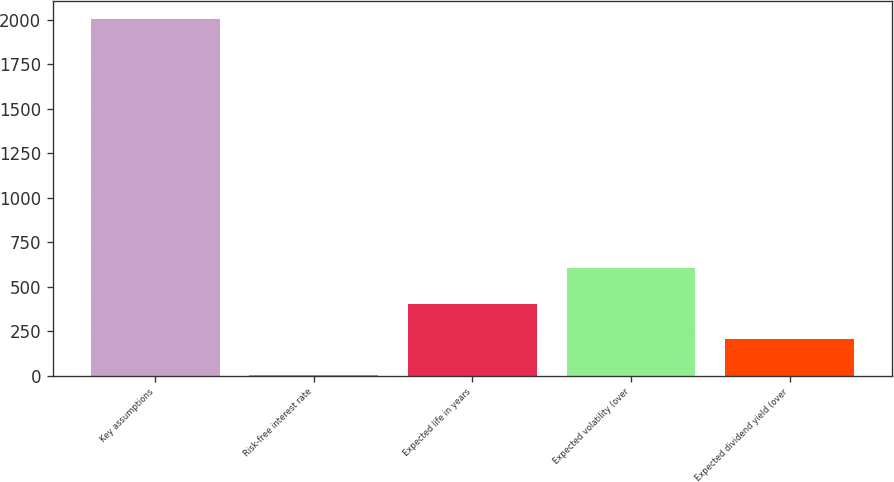<chart> <loc_0><loc_0><loc_500><loc_500><bar_chart><fcel>Key assumptions<fcel>Risk-free interest rate<fcel>Expected life in years<fcel>Expected volatility (over<fcel>Expected dividend yield (over<nl><fcel>2004<fcel>3.2<fcel>403.36<fcel>603.44<fcel>203.28<nl></chart> 